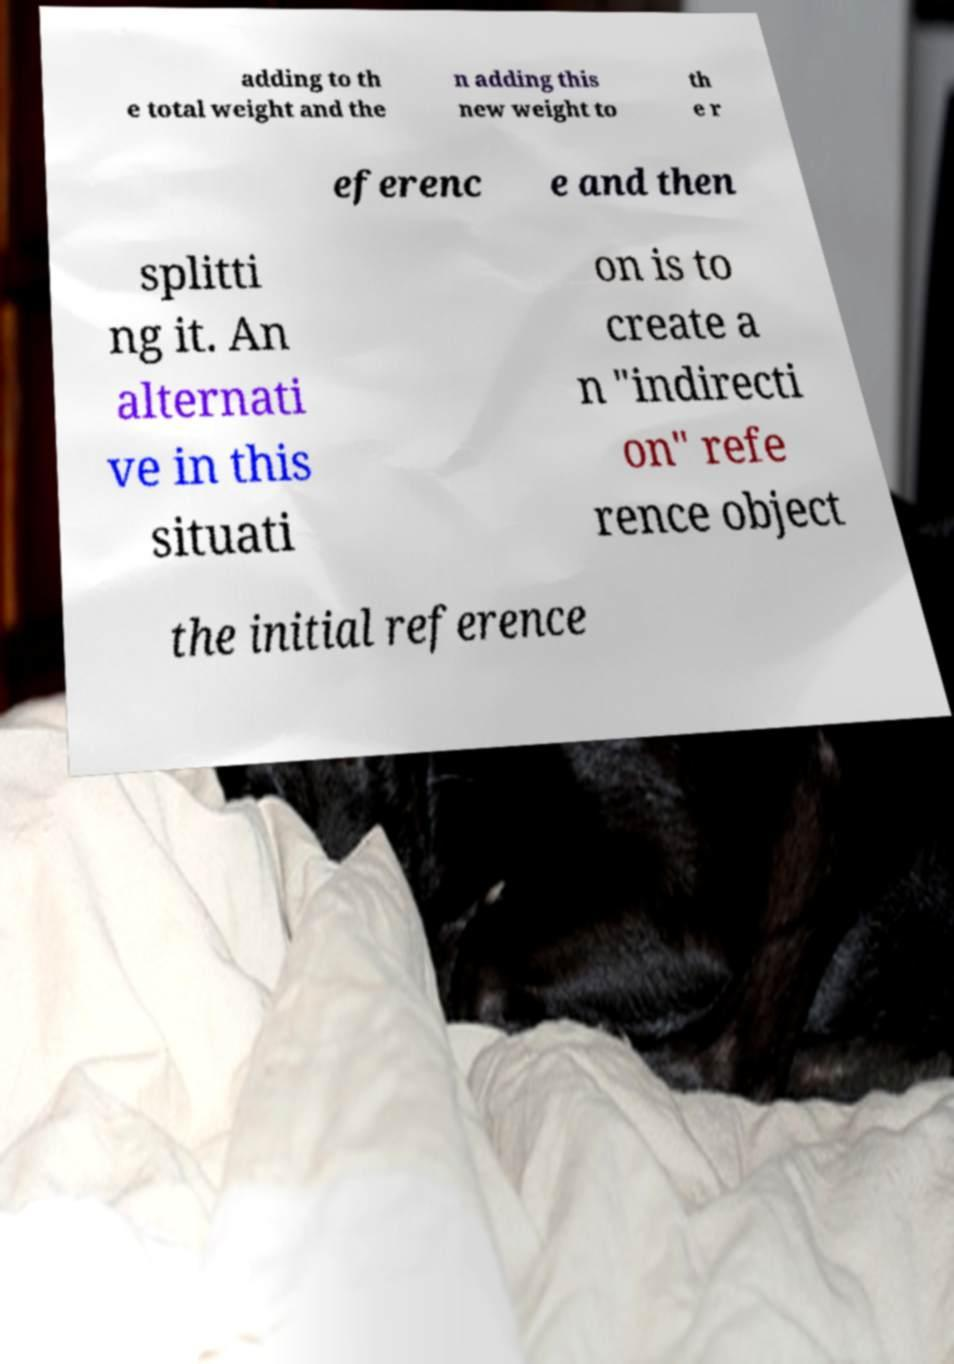Could you assist in decoding the text presented in this image and type it out clearly? adding to th e total weight and the n adding this new weight to th e r eferenc e and then splitti ng it. An alternati ve in this situati on is to create a n "indirecti on" refe rence object the initial reference 